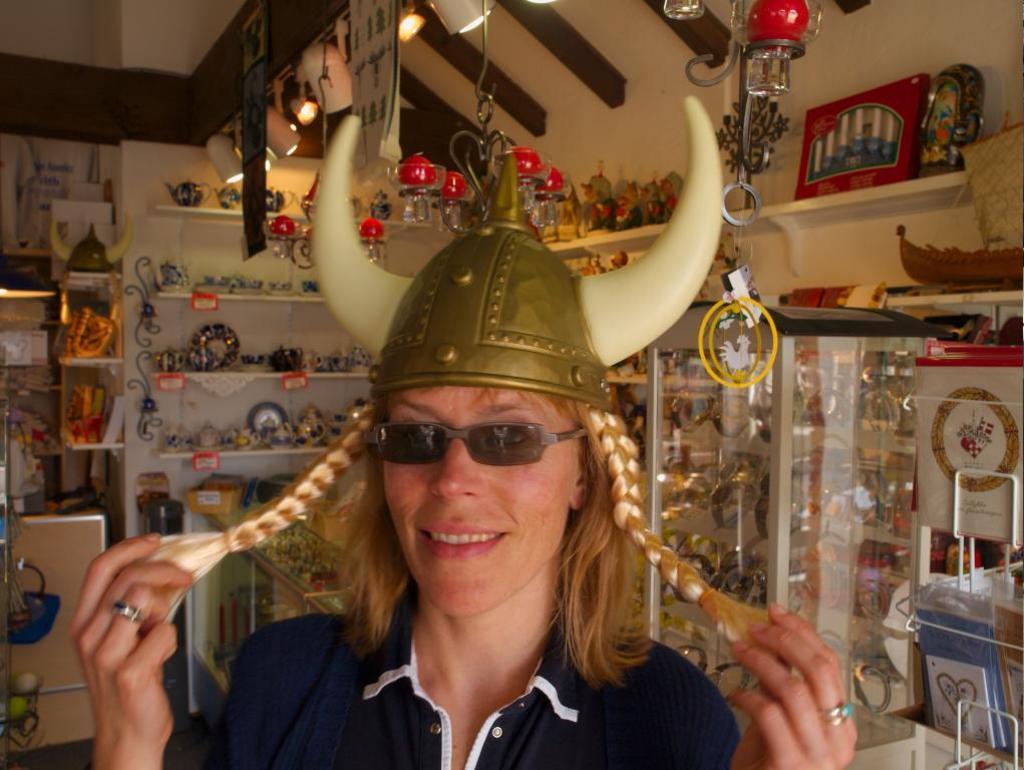Describe this image in one or two sentences. In this image I see a person who is wearing a t-shirt and I see that the person is wearing a helmet on his head. In the background I see number of things in these racks and I see the lights and I see the wall. 